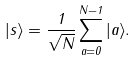Convert formula to latex. <formula><loc_0><loc_0><loc_500><loc_500>| s \rangle = \frac { 1 } { \sqrt { N } } \sum _ { a = 0 } ^ { N - 1 } | a \rangle .</formula> 